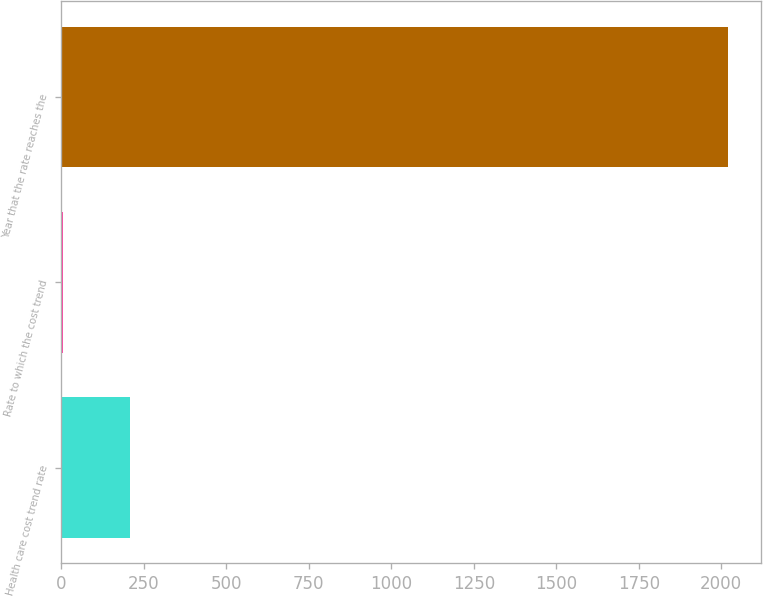Convert chart. <chart><loc_0><loc_0><loc_500><loc_500><bar_chart><fcel>Health care cost trend rate<fcel>Rate to which the cost trend<fcel>Year that the rate reaches the<nl><fcel>206.6<fcel>5<fcel>2021<nl></chart> 